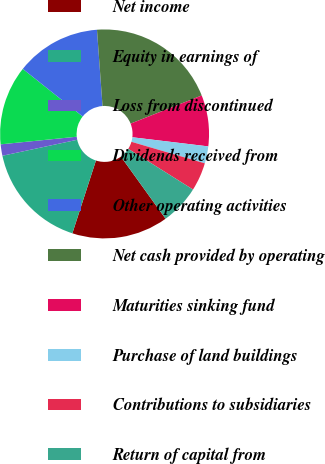Convert chart to OTSL. <chart><loc_0><loc_0><loc_500><loc_500><pie_chart><fcel>Net income<fcel>Equity in earnings of<fcel>Loss from discontinued<fcel>Dividends received from<fcel>Other operating activities<fcel>Net cash provided by operating<fcel>Maturities sinking fund<fcel>Purchase of land buildings<fcel>Contributions to subsidiaries<fcel>Return of capital from<nl><fcel>14.91%<fcel>16.66%<fcel>1.76%<fcel>12.28%<fcel>13.15%<fcel>20.16%<fcel>7.9%<fcel>2.64%<fcel>4.39%<fcel>6.14%<nl></chart> 